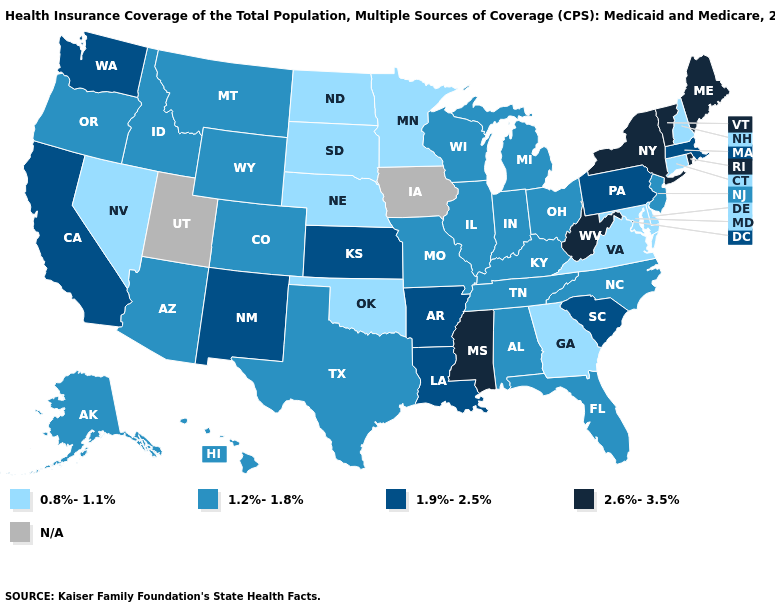Which states hav the highest value in the West?
Be succinct. California, New Mexico, Washington. What is the value of Vermont?
Answer briefly. 2.6%-3.5%. Name the states that have a value in the range 0.8%-1.1%?
Concise answer only. Connecticut, Delaware, Georgia, Maryland, Minnesota, Nebraska, Nevada, New Hampshire, North Dakota, Oklahoma, South Dakota, Virginia. Name the states that have a value in the range 2.6%-3.5%?
Give a very brief answer. Maine, Mississippi, New York, Rhode Island, Vermont, West Virginia. Among the states that border Montana , does South Dakota have the lowest value?
Answer briefly. Yes. Which states have the lowest value in the South?
Answer briefly. Delaware, Georgia, Maryland, Oklahoma, Virginia. Which states have the highest value in the USA?
Write a very short answer. Maine, Mississippi, New York, Rhode Island, Vermont, West Virginia. Is the legend a continuous bar?
Concise answer only. No. Among the states that border Connecticut , which have the lowest value?
Write a very short answer. Massachusetts. Name the states that have a value in the range 1.2%-1.8%?
Quick response, please. Alabama, Alaska, Arizona, Colorado, Florida, Hawaii, Idaho, Illinois, Indiana, Kentucky, Michigan, Missouri, Montana, New Jersey, North Carolina, Ohio, Oregon, Tennessee, Texas, Wisconsin, Wyoming. What is the value of Tennessee?
Keep it brief. 1.2%-1.8%. Does the first symbol in the legend represent the smallest category?
Answer briefly. Yes. Does Massachusetts have the lowest value in the USA?
Keep it brief. No. 